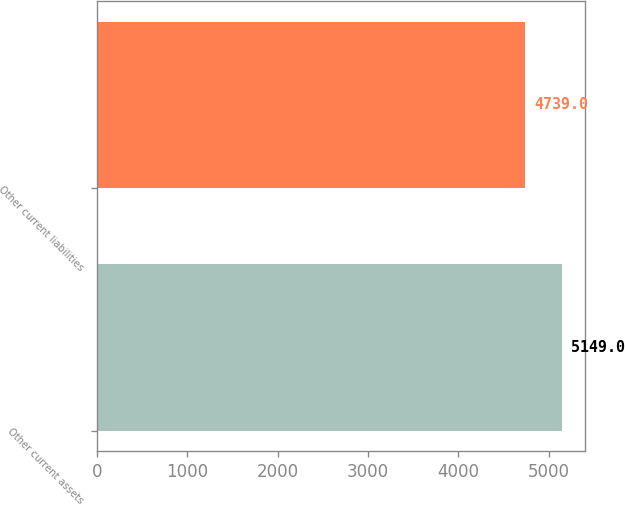Convert chart to OTSL. <chart><loc_0><loc_0><loc_500><loc_500><bar_chart><fcel>Other current assets<fcel>Other current liabilities<nl><fcel>5149<fcel>4739<nl></chart> 